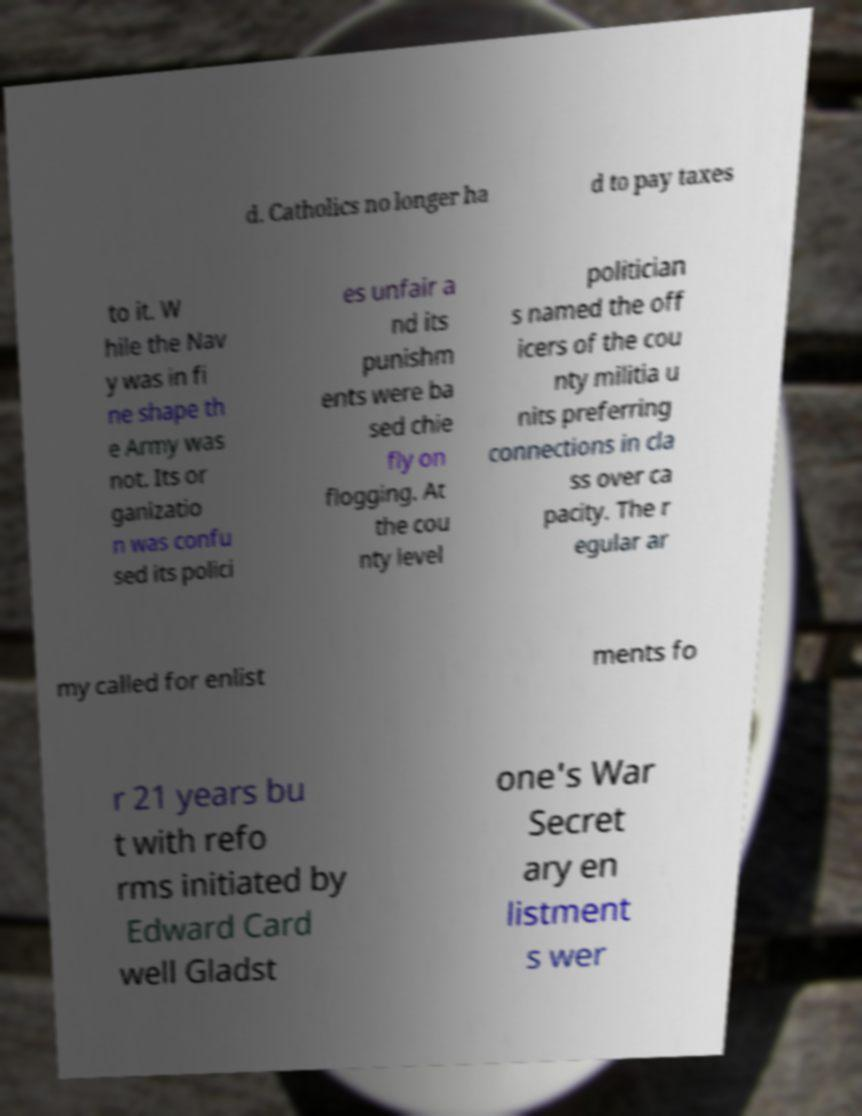There's text embedded in this image that I need extracted. Can you transcribe it verbatim? d. Catholics no longer ha d to pay taxes to it. W hile the Nav y was in fi ne shape th e Army was not. Its or ganizatio n was confu sed its polici es unfair a nd its punishm ents were ba sed chie fly on flogging. At the cou nty level politician s named the off icers of the cou nty militia u nits preferring connections in cla ss over ca pacity. The r egular ar my called for enlist ments fo r 21 years bu t with refo rms initiated by Edward Card well Gladst one's War Secret ary en listment s wer 